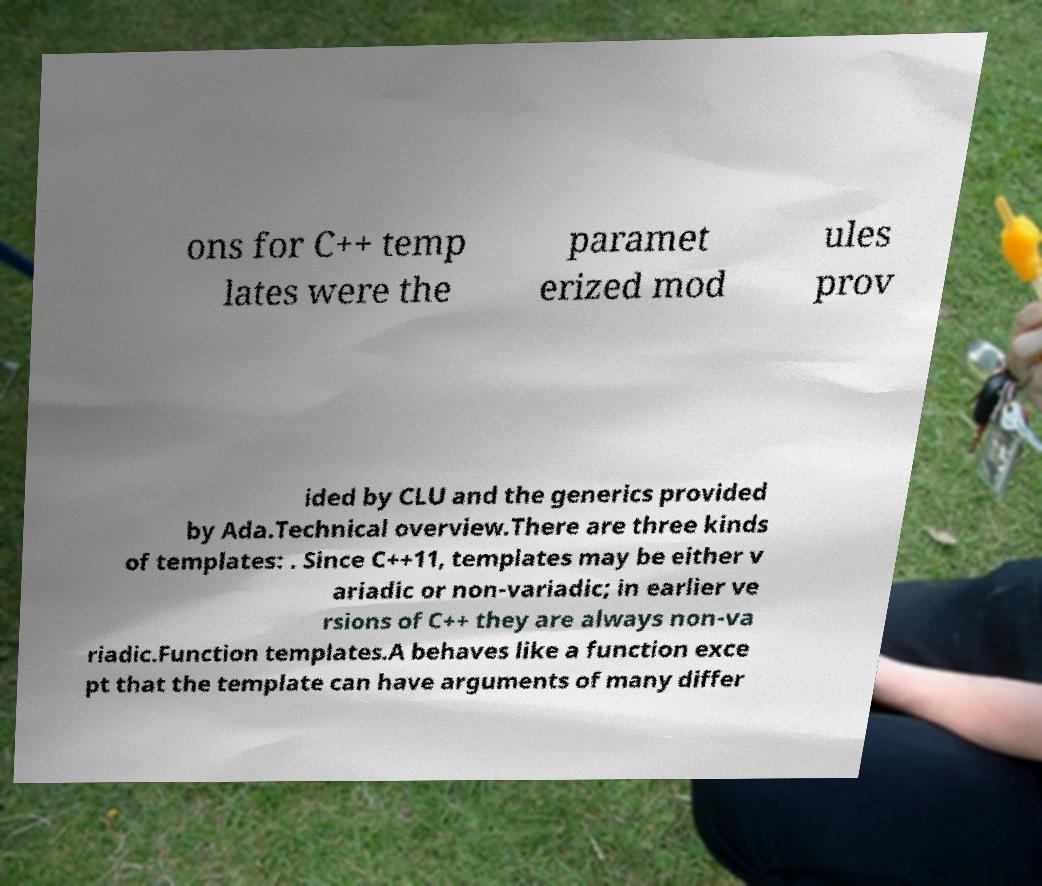Please identify and transcribe the text found in this image. ons for C++ temp lates were the paramet erized mod ules prov ided by CLU and the generics provided by Ada.Technical overview.There are three kinds of templates: . Since C++11, templates may be either v ariadic or non-variadic; in earlier ve rsions of C++ they are always non-va riadic.Function templates.A behaves like a function exce pt that the template can have arguments of many differ 